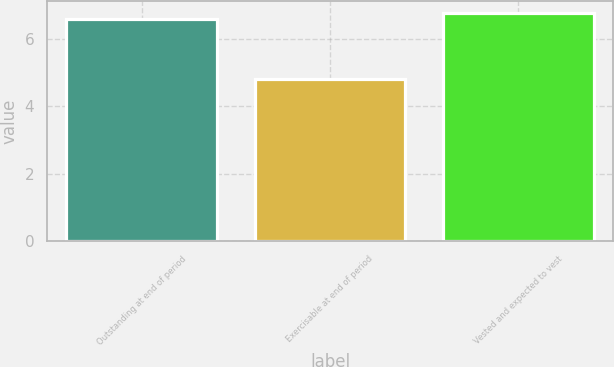<chart> <loc_0><loc_0><loc_500><loc_500><bar_chart><fcel>Outstanding at end of period<fcel>Exercisable at end of period<fcel>Vested and expected to vest<nl><fcel>6.6<fcel>4.8<fcel>6.78<nl></chart> 